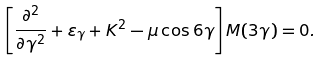<formula> <loc_0><loc_0><loc_500><loc_500>\left [ \frac { \partial ^ { 2 } } { \partial \gamma ^ { 2 } } + \varepsilon _ { \gamma } + K ^ { 2 } - \mu \cos 6 \gamma \right ] M ( 3 \gamma ) = 0 .</formula> 